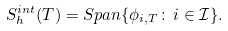Convert formula to latex. <formula><loc_0><loc_0><loc_500><loc_500>S _ { h } ^ { i n t } ( T ) = S p a n \{ \phi _ { i , T } \colon \, i \in \mathcal { I } \} .</formula> 